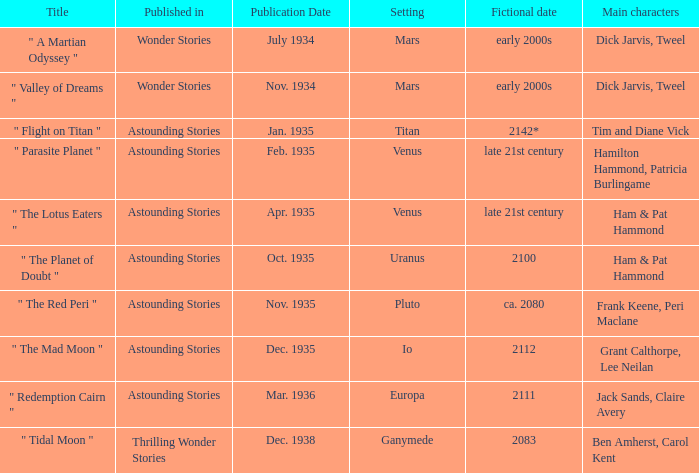Could you parse the entire table as a dict? {'header': ['Title', 'Published in', 'Publication Date', 'Setting', 'Fictional date', 'Main characters'], 'rows': [['" A Martian Odyssey "', 'Wonder Stories', 'July 1934', 'Mars', 'early 2000s', 'Dick Jarvis, Tweel'], ['" Valley of Dreams "', 'Wonder Stories', 'Nov. 1934', 'Mars', 'early 2000s', 'Dick Jarvis, Tweel'], ['" Flight on Titan "', 'Astounding Stories', 'Jan. 1935', 'Titan', '2142*', 'Tim and Diane Vick'], ['" Parasite Planet "', 'Astounding Stories', 'Feb. 1935', 'Venus', 'late 21st century', 'Hamilton Hammond, Patricia Burlingame'], ['" The Lotus Eaters "', 'Astounding Stories', 'Apr. 1935', 'Venus', 'late 21st century', 'Ham & Pat Hammond'], ['" The Planet of Doubt "', 'Astounding Stories', 'Oct. 1935', 'Uranus', '2100', 'Ham & Pat Hammond'], ['" The Red Peri "', 'Astounding Stories', 'Nov. 1935', 'Pluto', 'ca. 2080', 'Frank Keene, Peri Maclane'], ['" The Mad Moon "', 'Astounding Stories', 'Dec. 1935', 'Io', '2112', 'Grant Calthorpe, Lee Neilan'], ['" Redemption Cairn "', 'Astounding Stories', 'Mar. 1936', 'Europa', '2111', 'Jack Sands, Claire Avery'], ['" Tidal Moon "', 'Thrilling Wonder Stories', 'Dec. 1938', 'Ganymede', '2083', 'Ben Amherst, Carol Kent']]} What was the title of the piece published in july 1934 set on mars? Wonder Stories. 